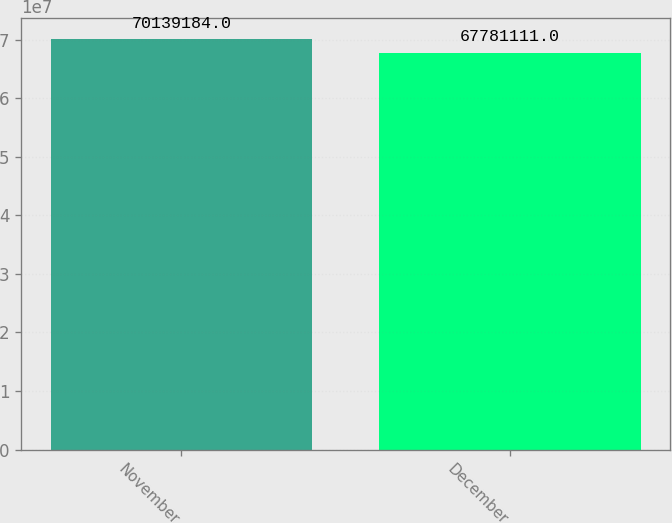Convert chart. <chart><loc_0><loc_0><loc_500><loc_500><bar_chart><fcel>November<fcel>December<nl><fcel>7.01392e+07<fcel>6.77811e+07<nl></chart> 